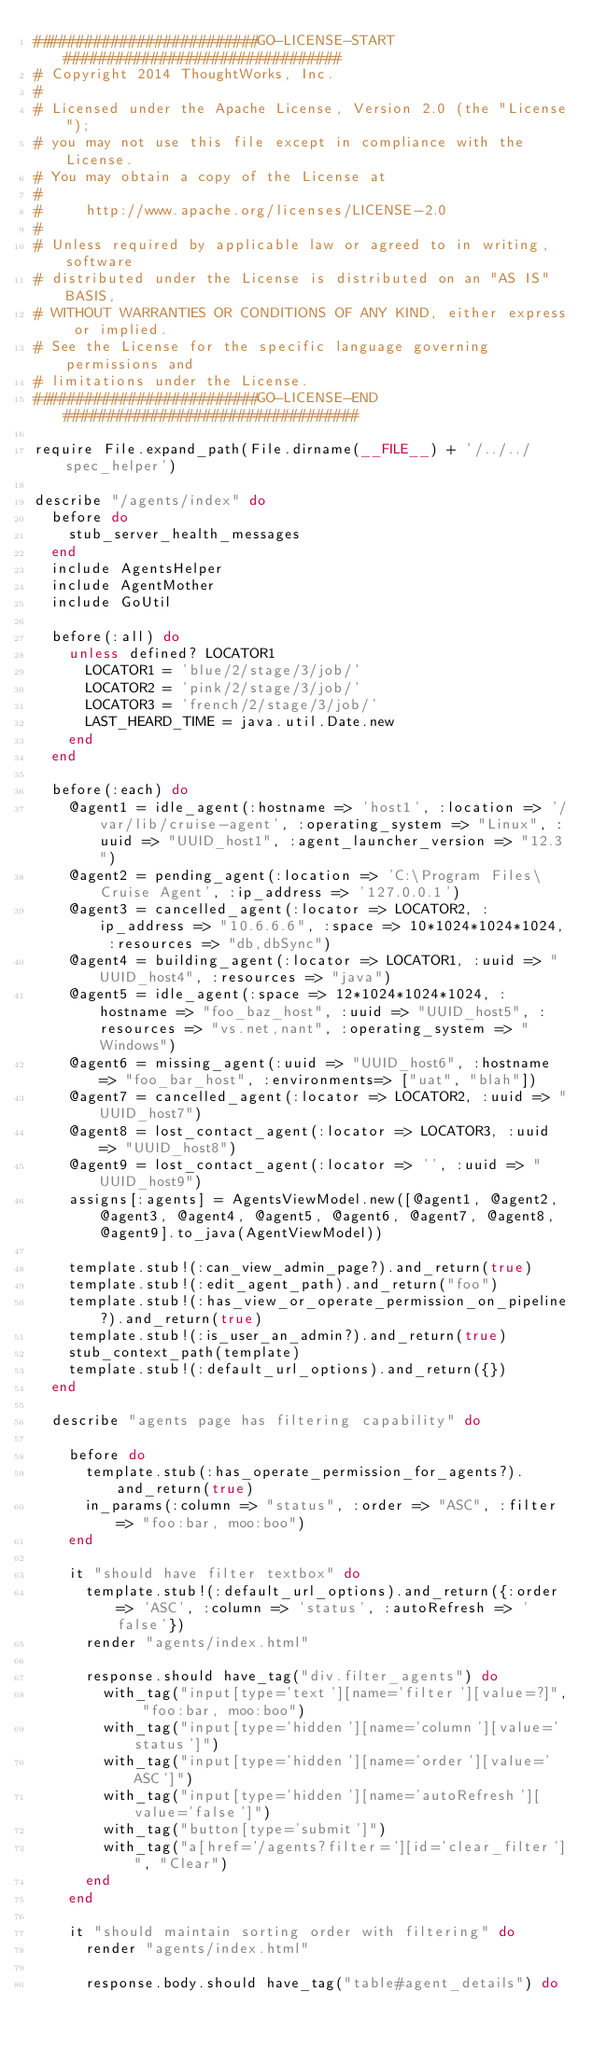<code> <loc_0><loc_0><loc_500><loc_500><_Ruby_>##########################GO-LICENSE-START################################
# Copyright 2014 ThoughtWorks, Inc.
#
# Licensed under the Apache License, Version 2.0 (the "License");
# you may not use this file except in compliance with the License.
# You may obtain a copy of the License at
#
#     http://www.apache.org/licenses/LICENSE-2.0
#
# Unless required by applicable law or agreed to in writing, software
# distributed under the License is distributed on an "AS IS" BASIS,
# WITHOUT WARRANTIES OR CONDITIONS OF ANY KIND, either express or implied.
# See the License for the specific language governing permissions and
# limitations under the License.
##########################GO-LICENSE-END##################################

require File.expand_path(File.dirname(__FILE__) + '/../../spec_helper')

describe "/agents/index" do
  before do
    stub_server_health_messages
  end
  include AgentsHelper
  include AgentMother
  include GoUtil

  before(:all) do
    unless defined? LOCATOR1
      LOCATOR1 = 'blue/2/stage/3/job/'
      LOCATOR2 = 'pink/2/stage/3/job/'
      LOCATOR3 = 'french/2/stage/3/job/'
      LAST_HEARD_TIME = java.util.Date.new
    end
  end

  before(:each) do
    @agent1 = idle_agent(:hostname => 'host1', :location => '/var/lib/cruise-agent', :operating_system => "Linux", :uuid => "UUID_host1", :agent_launcher_version => "12.3")
    @agent2 = pending_agent(:location => 'C:\Program Files\Cruise Agent', :ip_address => '127.0.0.1')
    @agent3 = cancelled_agent(:locator => LOCATOR2, :ip_address => "10.6.6.6", :space => 10*1024*1024*1024, :resources => "db,dbSync")
    @agent4 = building_agent(:locator => LOCATOR1, :uuid => "UUID_host4", :resources => "java")
    @agent5 = idle_agent(:space => 12*1024*1024*1024, :hostname => "foo_baz_host", :uuid => "UUID_host5", :resources => "vs.net,nant", :operating_system => "Windows")
    @agent6 = missing_agent(:uuid => "UUID_host6", :hostname => "foo_bar_host", :environments=> ["uat", "blah"])
    @agent7 = cancelled_agent(:locator => LOCATOR2, :uuid => "UUID_host7")
    @agent8 = lost_contact_agent(:locator => LOCATOR3, :uuid => "UUID_host8")
    @agent9 = lost_contact_agent(:locator => '', :uuid => "UUID_host9")
    assigns[:agents] = AgentsViewModel.new([@agent1, @agent2, @agent3, @agent4, @agent5, @agent6, @agent7, @agent8, @agent9].to_java(AgentViewModel))

    template.stub!(:can_view_admin_page?).and_return(true)
    template.stub!(:edit_agent_path).and_return("foo")
    template.stub!(:has_view_or_operate_permission_on_pipeline?).and_return(true)
    template.stub!(:is_user_an_admin?).and_return(true)
    stub_context_path(template)
    template.stub!(:default_url_options).and_return({})
  end

  describe "agents page has filtering capability" do

    before do
      template.stub(:has_operate_permission_for_agents?).and_return(true)
      in_params(:column => "status", :order => "ASC", :filter => "foo:bar, moo:boo")
    end

    it "should have filter textbox" do
      template.stub!(:default_url_options).and_return({:order => 'ASC', :column => 'status', :autoRefresh => 'false'})
      render "agents/index.html"

      response.should have_tag("div.filter_agents") do
        with_tag("input[type='text'][name='filter'][value=?]", "foo:bar, moo:boo")
        with_tag("input[type='hidden'][name='column'][value='status']")
        with_tag("input[type='hidden'][name='order'][value='ASC']")
        with_tag("input[type='hidden'][name='autoRefresh'][value='false']")
        with_tag("button[type='submit']")
        with_tag("a[href='/agents?filter='][id='clear_filter']", "Clear")
      end
    end

    it "should maintain sorting order with filtering" do
      render "agents/index.html"

      response.body.should have_tag("table#agent_details") do</code> 